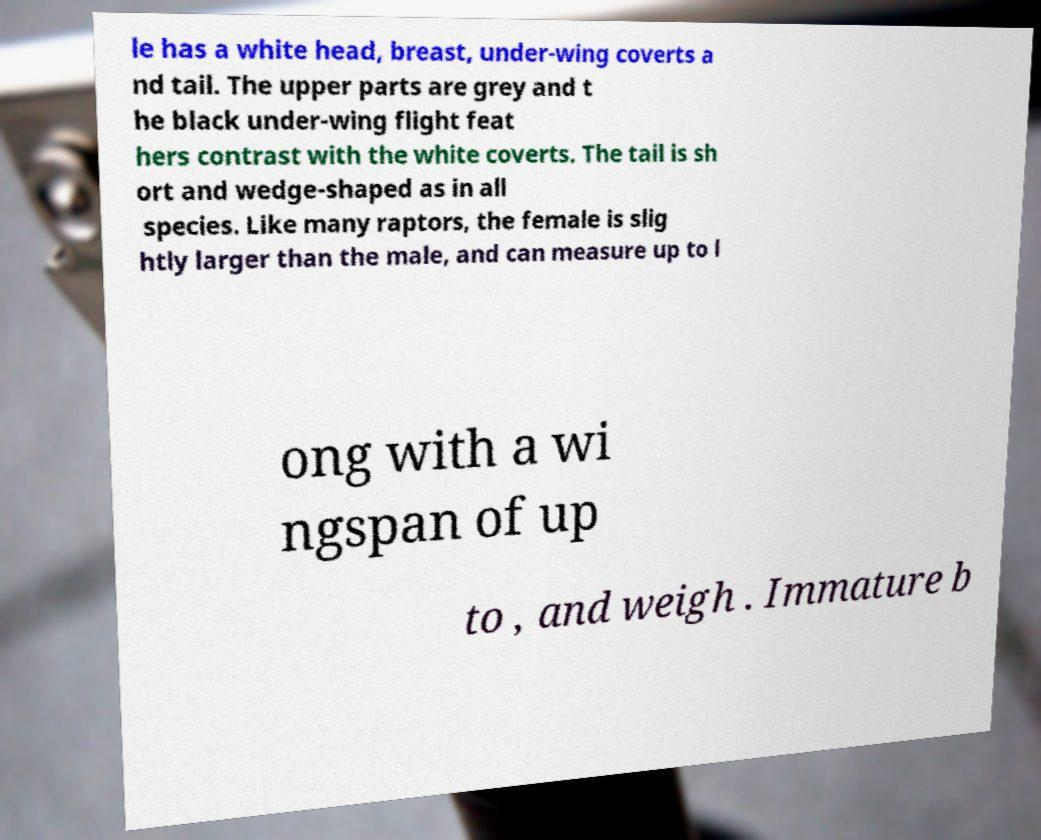For documentation purposes, I need the text within this image transcribed. Could you provide that? le has a white head, breast, under-wing coverts a nd tail. The upper parts are grey and t he black under-wing flight feat hers contrast with the white coverts. The tail is sh ort and wedge-shaped as in all species. Like many raptors, the female is slig htly larger than the male, and can measure up to l ong with a wi ngspan of up to , and weigh . Immature b 